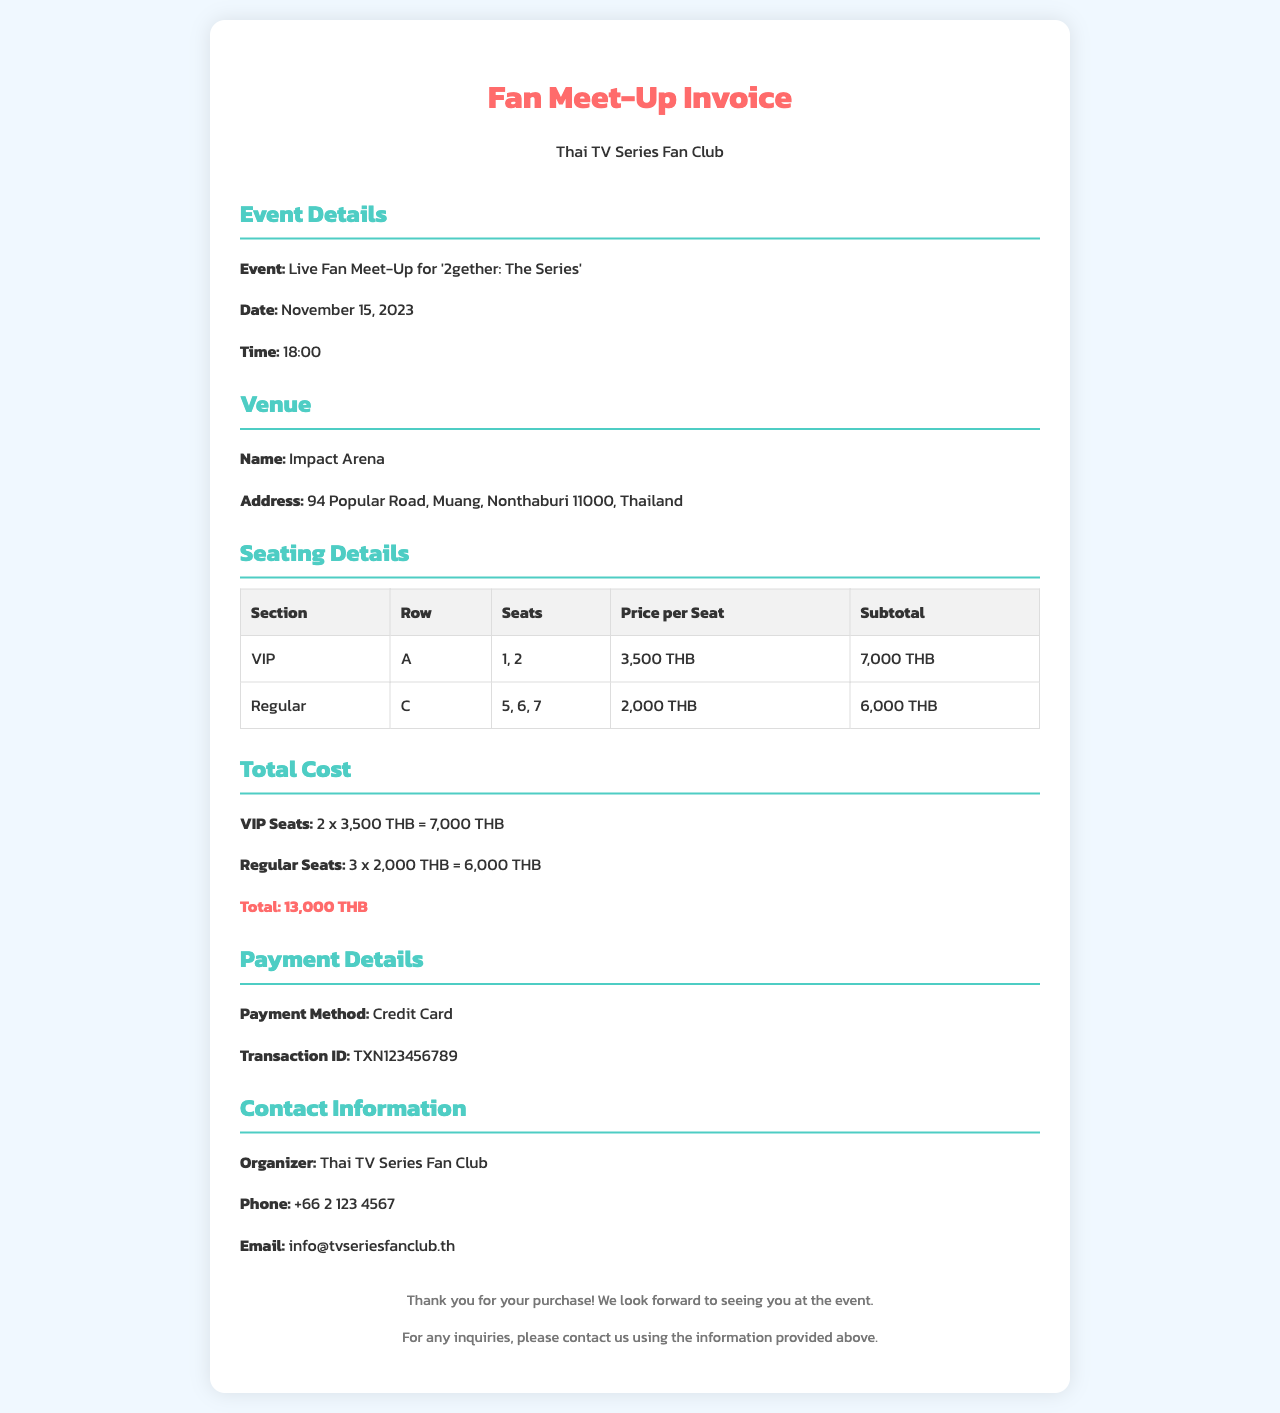what is the event name? The event name is specified under the event details section, which states the event is the Live Fan Meet-Up for '2gether: The Series'.
Answer: Live Fan Meet-Up for '2gether: The Series' what is the date of the event? The date is provided in the event details section, which indicates it is on November 15, 2023.
Answer: November 15, 2023 what is the total cost of the tickets? The total cost is calculated and presented in the total cost section, which sums up to 13,000 THB.
Answer: 13,000 THB how many VIP seats are included? The seating details specify that there are 2 VIP seats listed in the seating chart.
Answer: 2 where is the venue located? The venue address is detailed under the venue section, which states it is at 94 Popular Road, Muang, Nonthaburi 11000, Thailand.
Answer: 94 Popular Road, Muang, Nonthaburi 11000, Thailand what is the price per Regular seat? The price per Regular seat is mentioned in the seating details, which indicates it is 2,000 THB.
Answer: 2,000 THB who can be contacted for inquiries? The contact information section specifies that the organizer is Thai TV Series Fan Club, which can be contacted for inquiries.
Answer: Thai TV Series Fan Club what payment method was used? The payment method is stated in the payment details section, which identifies it as a Credit Card.
Answer: Credit Card what time does the event start? The event start time is noted in the event details, which specifies that it begins at 18:00.
Answer: 18:00 